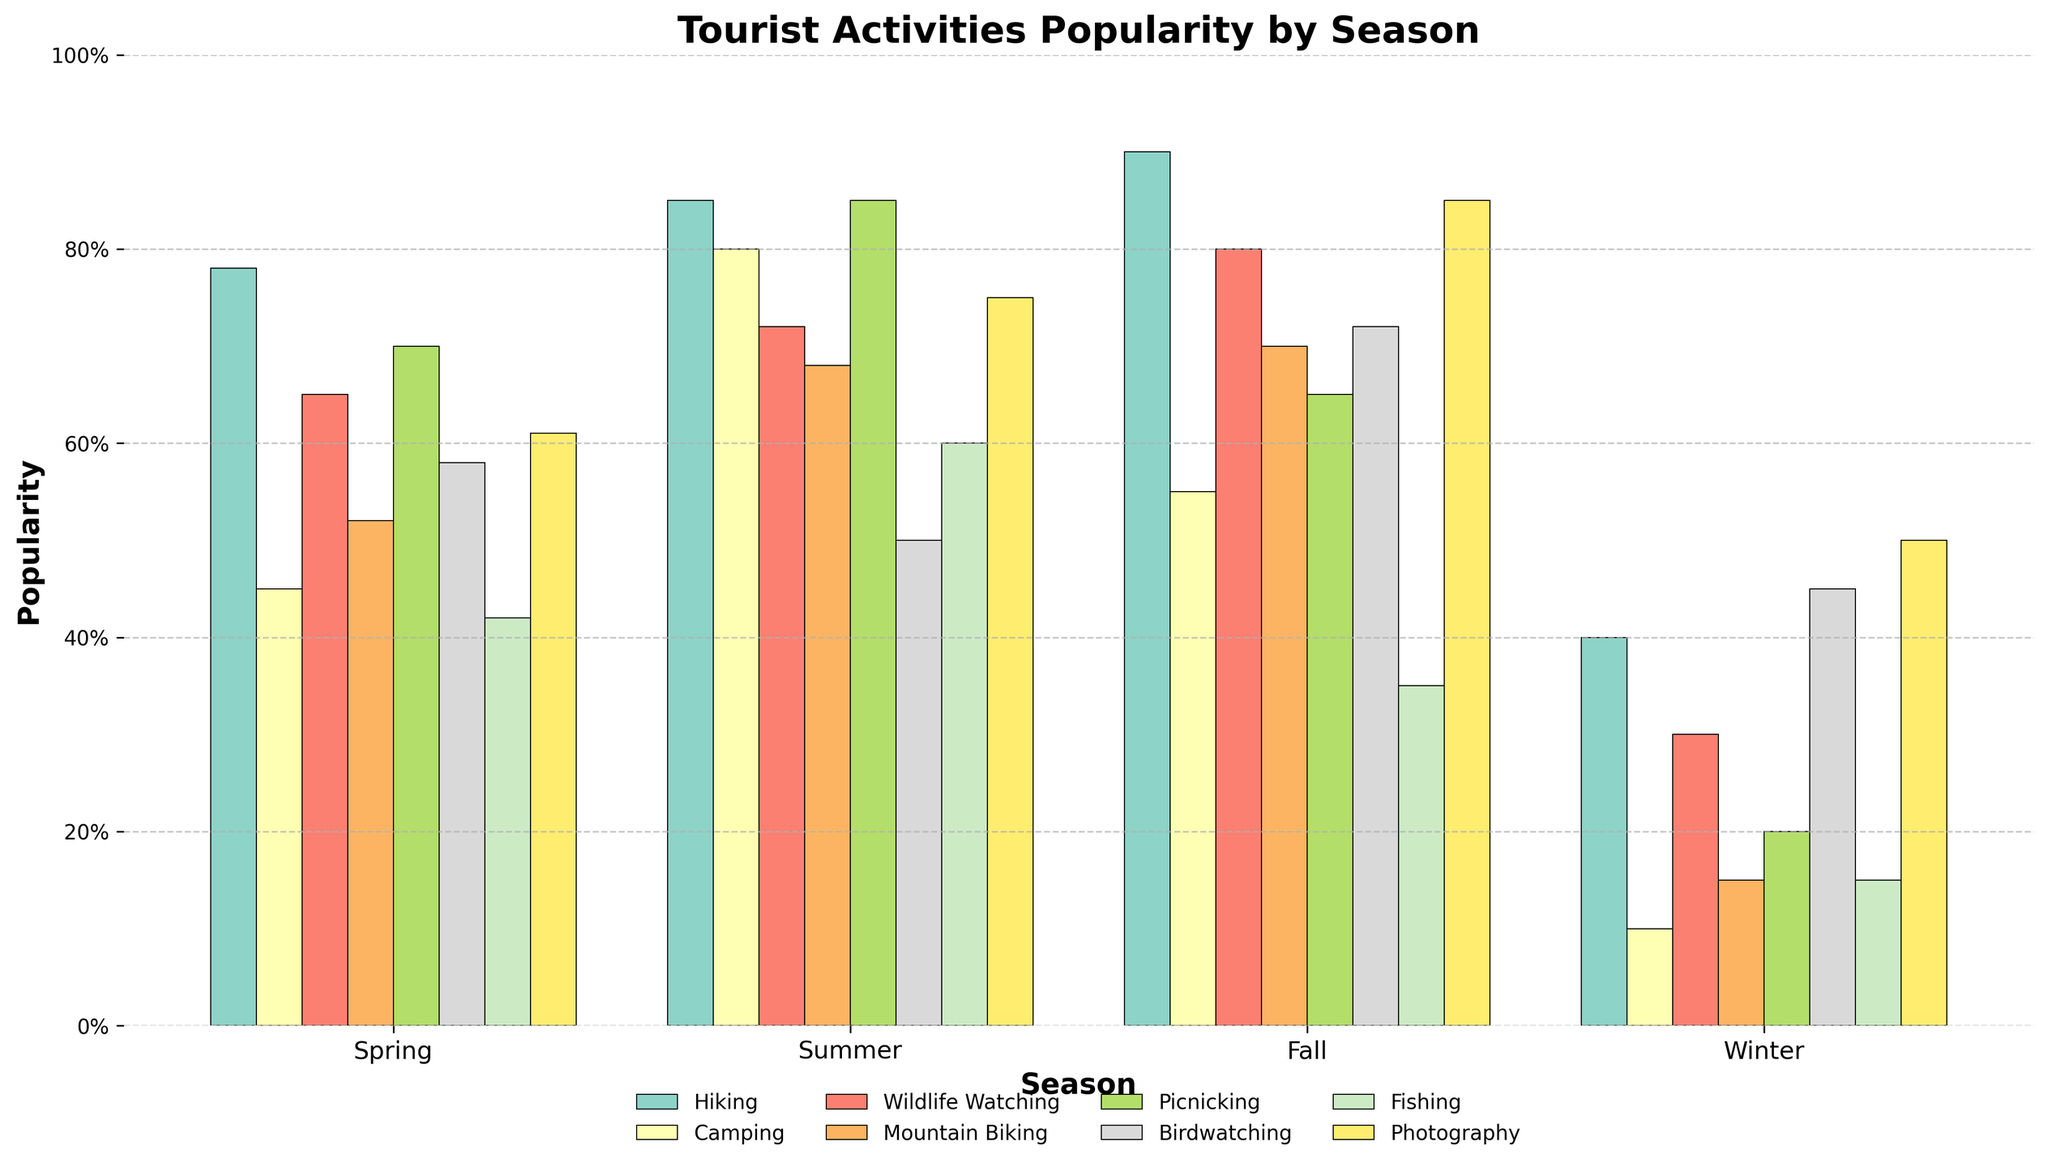Which season is the most popular for hiking? The height of the hiking bar is the highest in the fall season, indicating the number of people participating in hiking is highest in this season.
Answer: Fall How does the popularity of picnicking in summer compare to that in winter? The height of the picnicking bar is 85 in summer and 20 in winter, showing a significant decrease in popularity from summer to winter.
Answer: Much higher in summer What is the average popularity of wildlife watching across all seasons? To find the average, add the values for wildlife watching in all seasons (65 + 72 + 80 + 30) and divide by the number of seasons (4). So, (65 + 72 + 80 + 30)/4 = 61.75.
Answer: 61.75 In which season is camping less popular than birdwatching? By comparing the heights of the bars for camping and birdwatching, in spring camping (45) is less popular than birdwatching (58), and the same is true for fall (55 vs 72) and winter (10 vs 45).
Answer: Spring, Fall, Winter Which activity has the most even distribution of popularity across all seasons? Looking at the bars, photography has a relatively even distribution with values of 61, 75, 85, and 50 across spring, summer, fall, and winter respectively.
Answer: Photography What is the total popularity of fishing in the spring and summer seasons combined? Sum the fishing values for spring and summer, which are 42 and 60 respectively. Therefore, 42 + 60 = 102.
Answer: 102 How does the popularity of mountain biking in fall compare to spring? The height of the mountain biking bar in fall is 70, while in spring it is 52. This shows that mountain biking is slightly more popular in fall than in spring.
Answer: More popular in fall Which season has the highest overall activity participation? Summing up the values of all activities for each season: Spring (78+45+65+52+70+58+42+61=471), Summer (85+80+72+68+85+50+60+75=575), Fall (90+55+80+70+65+72+35+85=552), Winter (40+10+30+15+20+45+15+50=225). Summer has the highest total.
Answer: Summer 